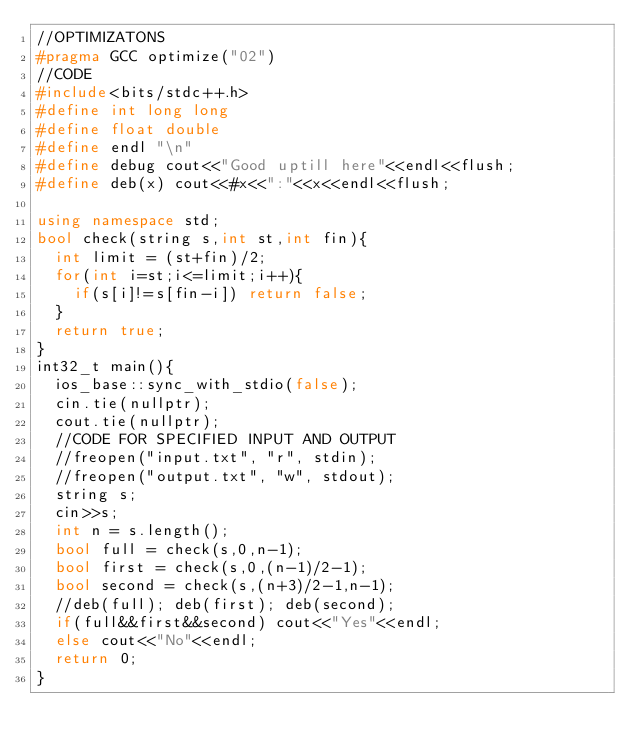<code> <loc_0><loc_0><loc_500><loc_500><_C++_>//OPTIMIZATONS
#pragma GCC optimize("02")
//CODE
#include<bits/stdc++.h>
#define int long long
#define float double
#define endl "\n"
#define debug cout<<"Good uptill here"<<endl<<flush;
#define deb(x) cout<<#x<<":"<<x<<endl<<flush;

using namespace std;
bool check(string s,int st,int fin){
	int limit = (st+fin)/2;
	for(int i=st;i<=limit;i++){
		if(s[i]!=s[fin-i]) return false;
	}
	return true;
}
int32_t main(){
	ios_base::sync_with_stdio(false);
	cin.tie(nullptr);
	cout.tie(nullptr);
	//CODE FOR SPECIFIED INPUT AND OUTPUT
	//freopen("input.txt", "r", stdin);
	//freopen("output.txt", "w", stdout);
	string s;
	cin>>s;
	int n = s.length();
	bool full = check(s,0,n-1);
	bool first = check(s,0,(n-1)/2-1);
	bool second = check(s,(n+3)/2-1,n-1);
	//deb(full); deb(first); deb(second);
	if(full&&first&&second) cout<<"Yes"<<endl;
	else cout<<"No"<<endl;
	return 0;
}

</code> 